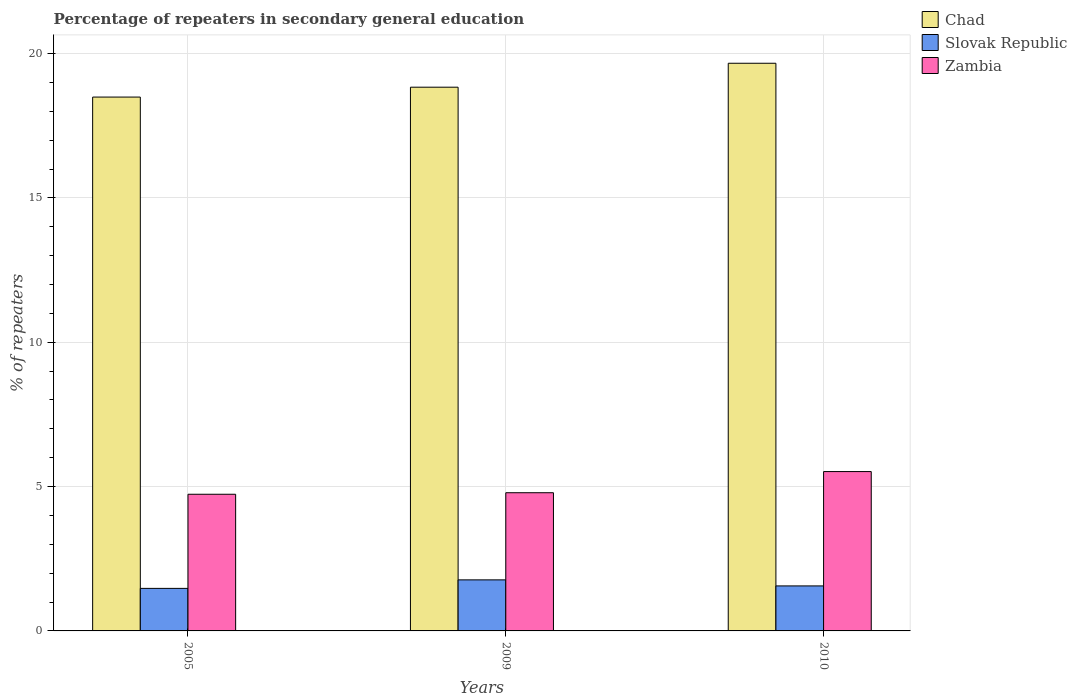Are the number of bars per tick equal to the number of legend labels?
Your answer should be very brief. Yes. Are the number of bars on each tick of the X-axis equal?
Your response must be concise. Yes. How many bars are there on the 2nd tick from the right?
Offer a terse response. 3. What is the percentage of repeaters in secondary general education in Chad in 2005?
Offer a very short reply. 18.49. Across all years, what is the maximum percentage of repeaters in secondary general education in Slovak Republic?
Offer a terse response. 1.77. Across all years, what is the minimum percentage of repeaters in secondary general education in Chad?
Keep it short and to the point. 18.49. What is the total percentage of repeaters in secondary general education in Slovak Republic in the graph?
Provide a short and direct response. 4.8. What is the difference between the percentage of repeaters in secondary general education in Zambia in 2009 and that in 2010?
Your answer should be very brief. -0.73. What is the difference between the percentage of repeaters in secondary general education in Chad in 2005 and the percentage of repeaters in secondary general education in Slovak Republic in 2009?
Offer a very short reply. 16.72. What is the average percentage of repeaters in secondary general education in Chad per year?
Your answer should be very brief. 19. In the year 2010, what is the difference between the percentage of repeaters in secondary general education in Zambia and percentage of repeaters in secondary general education in Chad?
Your answer should be very brief. -14.14. What is the ratio of the percentage of repeaters in secondary general education in Slovak Republic in 2009 to that in 2010?
Keep it short and to the point. 1.13. What is the difference between the highest and the second highest percentage of repeaters in secondary general education in Zambia?
Your answer should be very brief. 0.73. What is the difference between the highest and the lowest percentage of repeaters in secondary general education in Zambia?
Your answer should be very brief. 0.79. Is the sum of the percentage of repeaters in secondary general education in Chad in 2005 and 2010 greater than the maximum percentage of repeaters in secondary general education in Zambia across all years?
Your answer should be very brief. Yes. What does the 2nd bar from the left in 2009 represents?
Provide a short and direct response. Slovak Republic. What does the 3rd bar from the right in 2005 represents?
Make the answer very short. Chad. How many bars are there?
Provide a short and direct response. 9. Are all the bars in the graph horizontal?
Provide a short and direct response. No. What is the difference between two consecutive major ticks on the Y-axis?
Ensure brevity in your answer.  5. Does the graph contain any zero values?
Your response must be concise. No. Does the graph contain grids?
Your answer should be compact. Yes. How many legend labels are there?
Your response must be concise. 3. What is the title of the graph?
Provide a succinct answer. Percentage of repeaters in secondary general education. What is the label or title of the X-axis?
Offer a terse response. Years. What is the label or title of the Y-axis?
Your answer should be very brief. % of repeaters. What is the % of repeaters of Chad in 2005?
Make the answer very short. 18.49. What is the % of repeaters of Slovak Republic in 2005?
Your response must be concise. 1.47. What is the % of repeaters in Zambia in 2005?
Your answer should be very brief. 4.73. What is the % of repeaters in Chad in 2009?
Your response must be concise. 18.83. What is the % of repeaters in Slovak Republic in 2009?
Ensure brevity in your answer.  1.77. What is the % of repeaters in Zambia in 2009?
Make the answer very short. 4.79. What is the % of repeaters of Chad in 2010?
Your answer should be compact. 19.66. What is the % of repeaters of Slovak Republic in 2010?
Offer a terse response. 1.56. What is the % of repeaters of Zambia in 2010?
Provide a succinct answer. 5.52. Across all years, what is the maximum % of repeaters of Chad?
Provide a short and direct response. 19.66. Across all years, what is the maximum % of repeaters in Slovak Republic?
Your answer should be compact. 1.77. Across all years, what is the maximum % of repeaters of Zambia?
Offer a very short reply. 5.52. Across all years, what is the minimum % of repeaters of Chad?
Ensure brevity in your answer.  18.49. Across all years, what is the minimum % of repeaters of Slovak Republic?
Your answer should be compact. 1.47. Across all years, what is the minimum % of repeaters of Zambia?
Your response must be concise. 4.73. What is the total % of repeaters of Chad in the graph?
Give a very brief answer. 56.99. What is the total % of repeaters in Slovak Republic in the graph?
Offer a terse response. 4.8. What is the total % of repeaters in Zambia in the graph?
Your answer should be very brief. 15.04. What is the difference between the % of repeaters in Chad in 2005 and that in 2009?
Give a very brief answer. -0.34. What is the difference between the % of repeaters of Slovak Republic in 2005 and that in 2009?
Offer a very short reply. -0.29. What is the difference between the % of repeaters of Zambia in 2005 and that in 2009?
Ensure brevity in your answer.  -0.05. What is the difference between the % of repeaters of Chad in 2005 and that in 2010?
Your answer should be compact. -1.17. What is the difference between the % of repeaters in Slovak Republic in 2005 and that in 2010?
Make the answer very short. -0.09. What is the difference between the % of repeaters of Zambia in 2005 and that in 2010?
Your response must be concise. -0.79. What is the difference between the % of repeaters in Chad in 2009 and that in 2010?
Make the answer very short. -0.83. What is the difference between the % of repeaters of Slovak Republic in 2009 and that in 2010?
Provide a short and direct response. 0.21. What is the difference between the % of repeaters of Zambia in 2009 and that in 2010?
Provide a succinct answer. -0.73. What is the difference between the % of repeaters of Chad in 2005 and the % of repeaters of Slovak Republic in 2009?
Provide a short and direct response. 16.72. What is the difference between the % of repeaters in Chad in 2005 and the % of repeaters in Zambia in 2009?
Provide a succinct answer. 13.71. What is the difference between the % of repeaters of Slovak Republic in 2005 and the % of repeaters of Zambia in 2009?
Ensure brevity in your answer.  -3.31. What is the difference between the % of repeaters in Chad in 2005 and the % of repeaters in Slovak Republic in 2010?
Give a very brief answer. 16.93. What is the difference between the % of repeaters of Chad in 2005 and the % of repeaters of Zambia in 2010?
Provide a succinct answer. 12.97. What is the difference between the % of repeaters of Slovak Republic in 2005 and the % of repeaters of Zambia in 2010?
Your answer should be compact. -4.05. What is the difference between the % of repeaters of Chad in 2009 and the % of repeaters of Slovak Republic in 2010?
Ensure brevity in your answer.  17.28. What is the difference between the % of repeaters of Chad in 2009 and the % of repeaters of Zambia in 2010?
Provide a short and direct response. 13.31. What is the difference between the % of repeaters in Slovak Republic in 2009 and the % of repeaters in Zambia in 2010?
Ensure brevity in your answer.  -3.75. What is the average % of repeaters in Chad per year?
Give a very brief answer. 19. What is the average % of repeaters in Slovak Republic per year?
Provide a succinct answer. 1.6. What is the average % of repeaters in Zambia per year?
Provide a succinct answer. 5.01. In the year 2005, what is the difference between the % of repeaters in Chad and % of repeaters in Slovak Republic?
Keep it short and to the point. 17.02. In the year 2005, what is the difference between the % of repeaters of Chad and % of repeaters of Zambia?
Ensure brevity in your answer.  13.76. In the year 2005, what is the difference between the % of repeaters of Slovak Republic and % of repeaters of Zambia?
Make the answer very short. -3.26. In the year 2009, what is the difference between the % of repeaters in Chad and % of repeaters in Slovak Republic?
Your answer should be compact. 17.07. In the year 2009, what is the difference between the % of repeaters of Chad and % of repeaters of Zambia?
Give a very brief answer. 14.05. In the year 2009, what is the difference between the % of repeaters of Slovak Republic and % of repeaters of Zambia?
Make the answer very short. -3.02. In the year 2010, what is the difference between the % of repeaters of Chad and % of repeaters of Slovak Republic?
Offer a terse response. 18.1. In the year 2010, what is the difference between the % of repeaters of Chad and % of repeaters of Zambia?
Provide a short and direct response. 14.14. In the year 2010, what is the difference between the % of repeaters in Slovak Republic and % of repeaters in Zambia?
Give a very brief answer. -3.96. What is the ratio of the % of repeaters in Chad in 2005 to that in 2009?
Make the answer very short. 0.98. What is the ratio of the % of repeaters of Slovak Republic in 2005 to that in 2009?
Your answer should be compact. 0.83. What is the ratio of the % of repeaters of Zambia in 2005 to that in 2009?
Give a very brief answer. 0.99. What is the ratio of the % of repeaters in Chad in 2005 to that in 2010?
Provide a succinct answer. 0.94. What is the ratio of the % of repeaters of Slovak Republic in 2005 to that in 2010?
Keep it short and to the point. 0.95. What is the ratio of the % of repeaters of Zambia in 2005 to that in 2010?
Your answer should be very brief. 0.86. What is the ratio of the % of repeaters of Chad in 2009 to that in 2010?
Provide a succinct answer. 0.96. What is the ratio of the % of repeaters of Slovak Republic in 2009 to that in 2010?
Ensure brevity in your answer.  1.13. What is the ratio of the % of repeaters in Zambia in 2009 to that in 2010?
Offer a terse response. 0.87. What is the difference between the highest and the second highest % of repeaters of Chad?
Your answer should be very brief. 0.83. What is the difference between the highest and the second highest % of repeaters of Slovak Republic?
Ensure brevity in your answer.  0.21. What is the difference between the highest and the second highest % of repeaters of Zambia?
Keep it short and to the point. 0.73. What is the difference between the highest and the lowest % of repeaters in Chad?
Make the answer very short. 1.17. What is the difference between the highest and the lowest % of repeaters of Slovak Republic?
Your response must be concise. 0.29. What is the difference between the highest and the lowest % of repeaters in Zambia?
Provide a succinct answer. 0.79. 